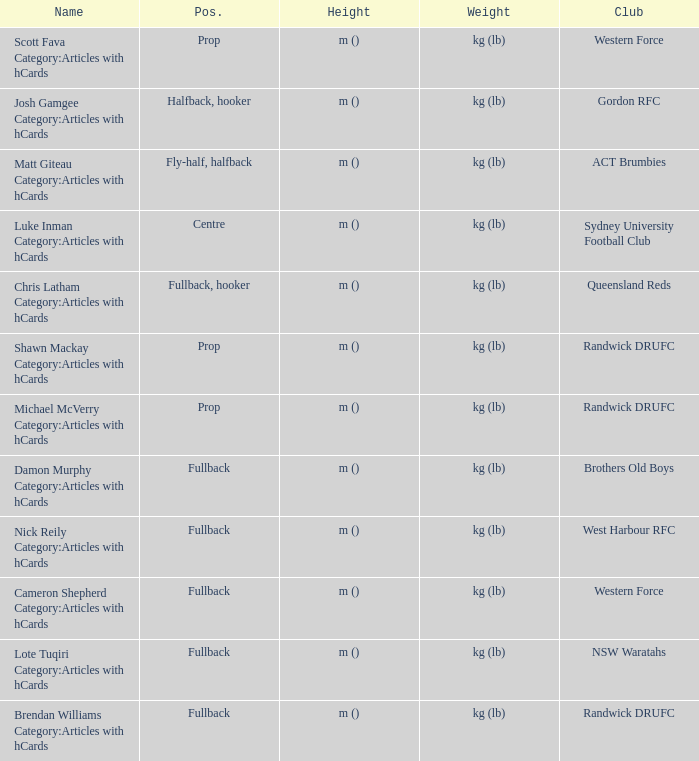What is the term when the location is central? Luke Inman Category:Articles with hCards. 